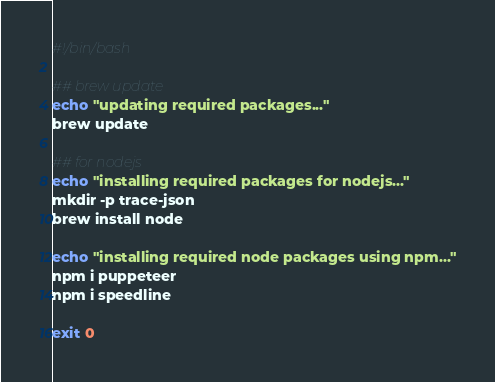<code> <loc_0><loc_0><loc_500><loc_500><_Bash_>#!/bin/bash

## brew update
echo "updating required packages..."
brew update

## for nodejs
echo "installing required packages for nodejs..."
mkdir -p trace-json
brew install node

echo "installing required node packages using npm..."
npm i puppeteer
npm i speedline

exit 0
</code> 